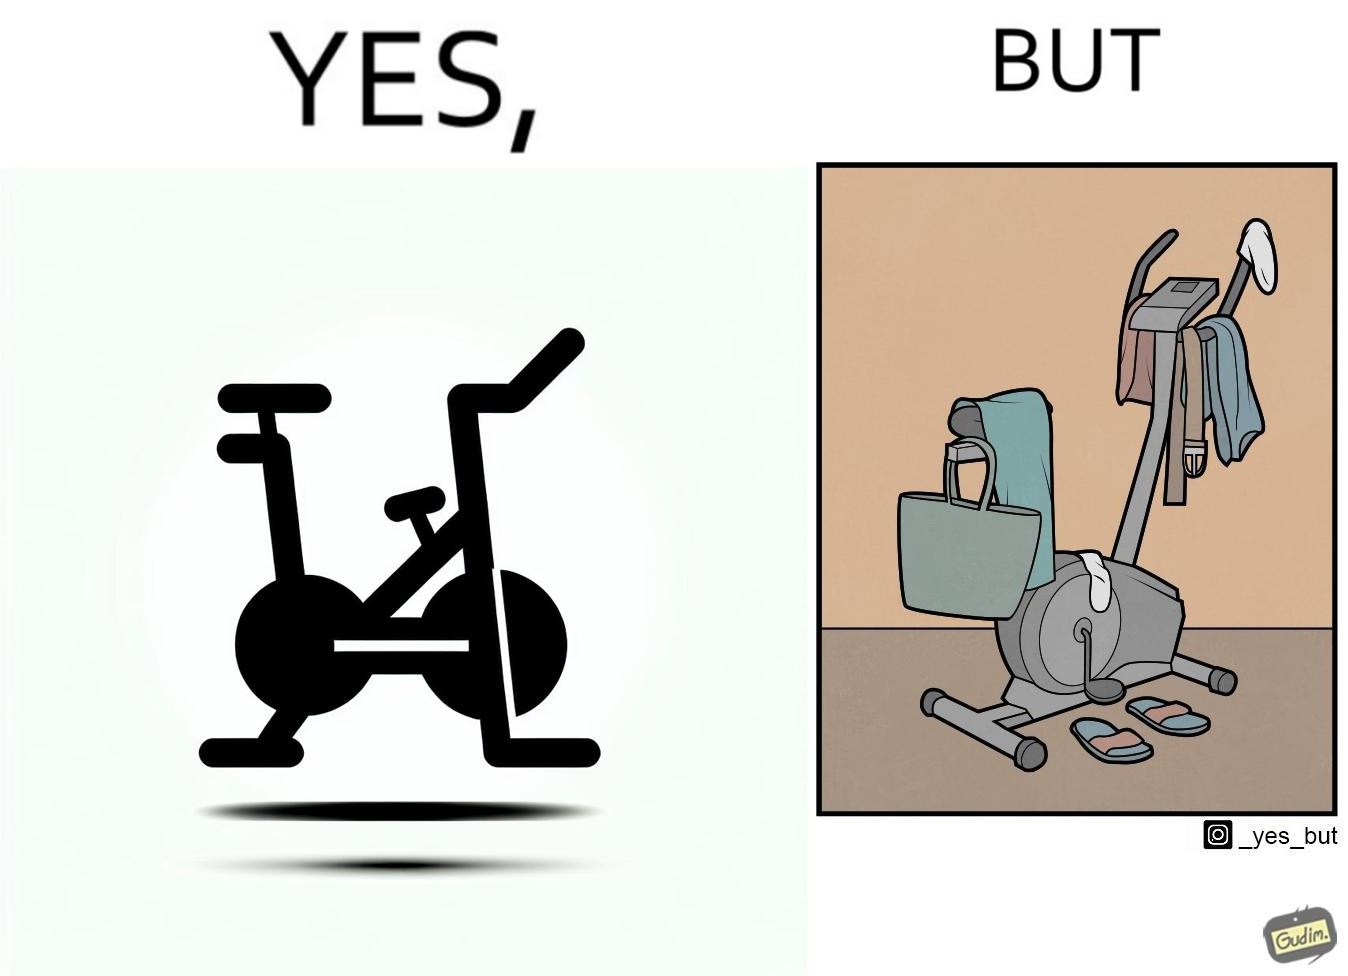Is this a satirical image? Yes, this image is satirical. 